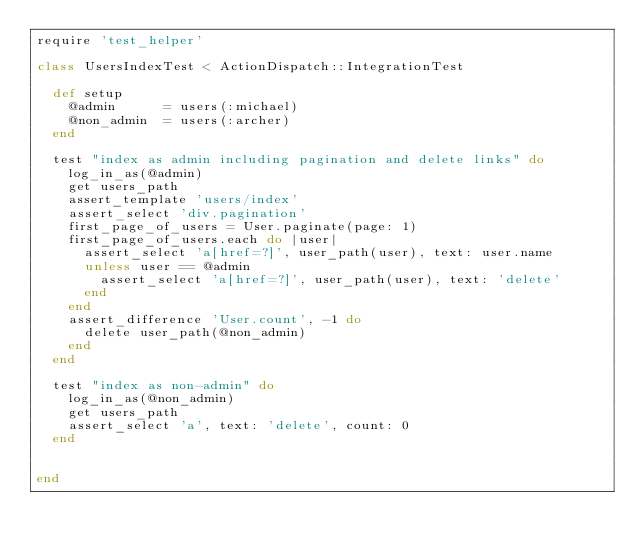<code> <loc_0><loc_0><loc_500><loc_500><_Ruby_>require 'test_helper'

class UsersIndexTest < ActionDispatch::IntegrationTest

	def setup
		@admin			= users(:michael)
		@non_admin	= users(:archer)
	end

	test "index as admin including pagination and delete links" do
		log_in_as(@admin)
		get users_path
		assert_template 'users/index'
		assert_select 'div.pagination'
		first_page_of_users = User.paginate(page: 1)
		first_page_of_users.each do |user|
			assert_select 'a[href=?]', user_path(user), text: user.name
			unless user == @admin
				assert_select 'a[href=?]', user_path(user), text: 'delete'
			end
		end
		assert_difference 'User.count', -1 do
			delete user_path(@non_admin)
		end
	end

	test "index as non-admin" do
		log_in_as(@non_admin)
		get users_path
		assert_select 'a', text: 'delete', count: 0
	end


end
</code> 